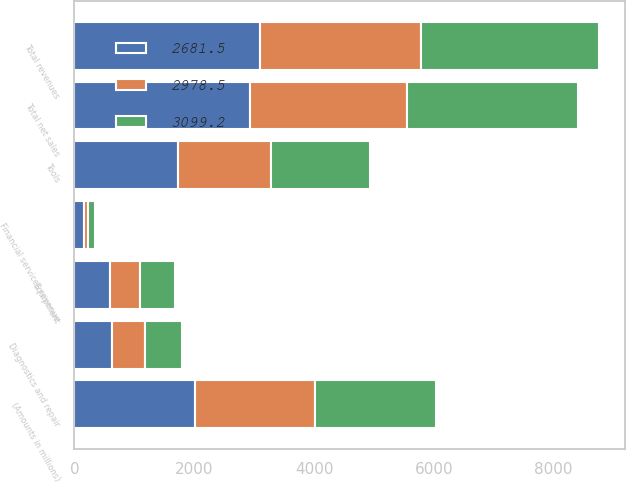Convert chart to OTSL. <chart><loc_0><loc_0><loc_500><loc_500><stacked_bar_chart><ecel><fcel>(Amounts in millions)<fcel>Tools<fcel>Diagnostics and repair<fcel>Equipment<fcel>Total net sales<fcel>Financial services revenue<fcel>Total revenues<nl><fcel>2681.5<fcel>2012<fcel>1729.4<fcel>619.8<fcel>588.7<fcel>2937.9<fcel>161.3<fcel>3099.2<nl><fcel>3099.2<fcel>2011<fcel>1667.3<fcel>613.7<fcel>573.2<fcel>2854.2<fcel>124.3<fcel>2978.5<nl><fcel>2978.5<fcel>2010<fcel>1545.1<fcel>563.3<fcel>510.8<fcel>2619.2<fcel>62.3<fcel>2681.5<nl></chart> 